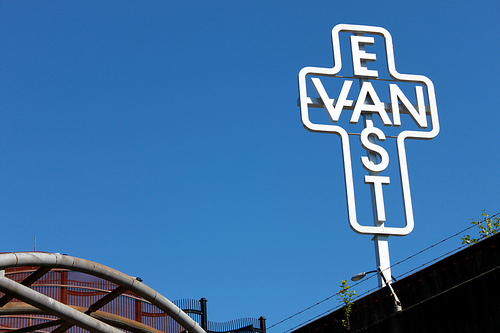<image>
Is there a sign in the sky? No. The sign is not contained within the sky. These objects have a different spatial relationship. 